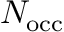<formula> <loc_0><loc_0><loc_500><loc_500>N _ { o c c }</formula> 